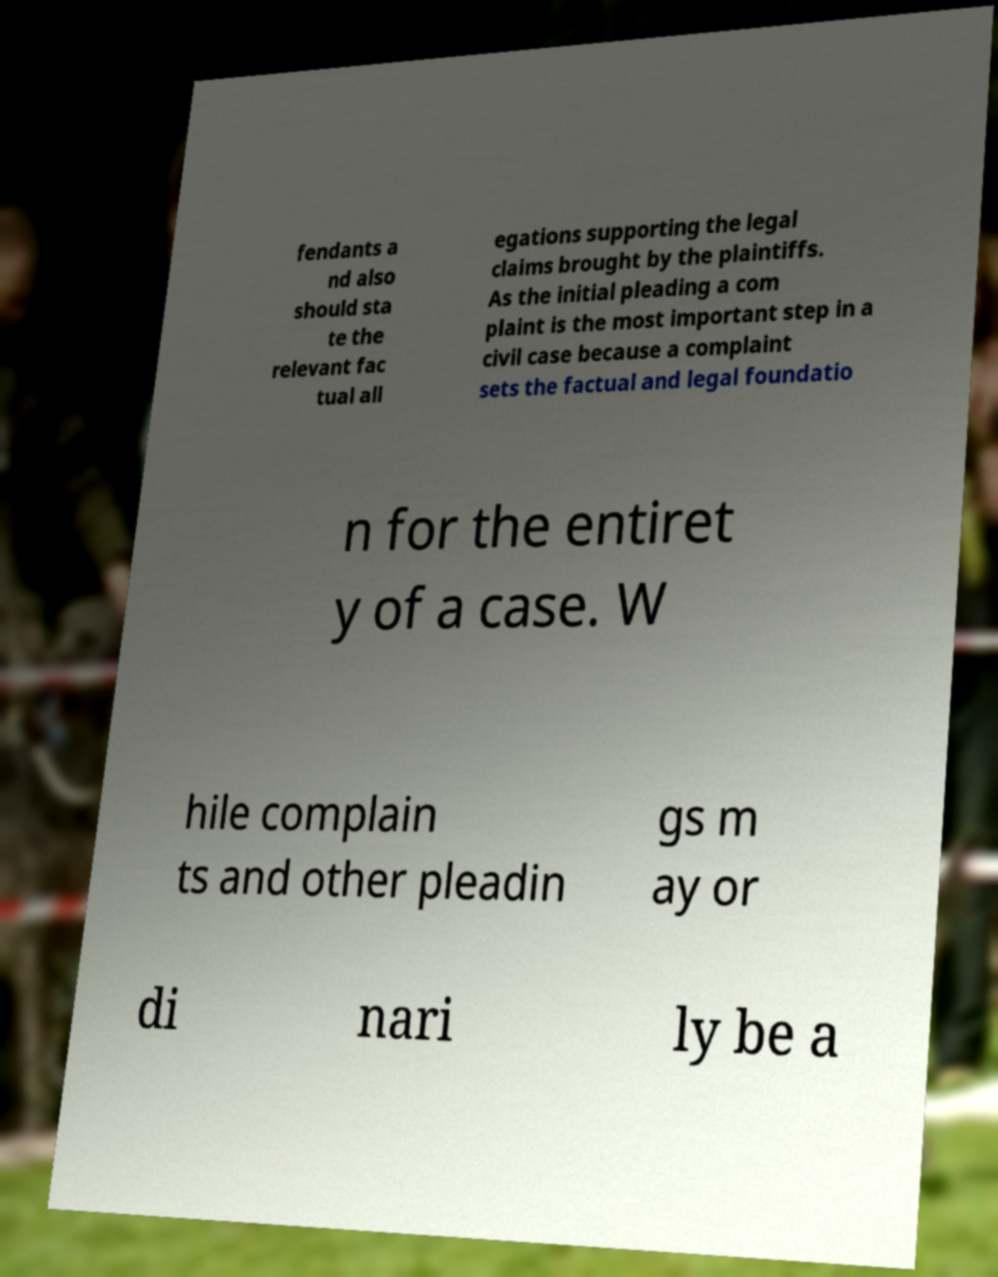There's text embedded in this image that I need extracted. Can you transcribe it verbatim? fendants a nd also should sta te the relevant fac tual all egations supporting the legal claims brought by the plaintiffs. As the initial pleading a com plaint is the most important step in a civil case because a complaint sets the factual and legal foundatio n for the entiret y of a case. W hile complain ts and other pleadin gs m ay or di nari ly be a 